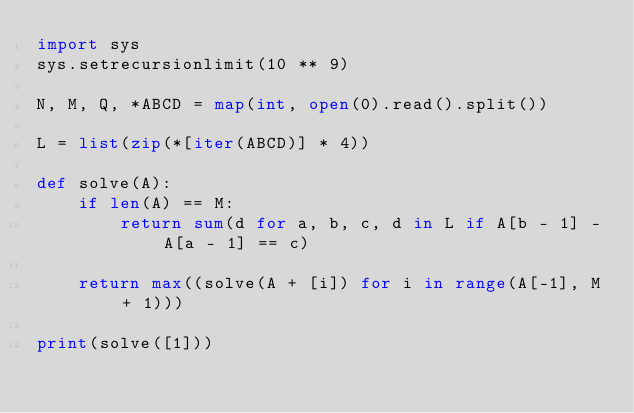Convert code to text. <code><loc_0><loc_0><loc_500><loc_500><_Python_>import sys
sys.setrecursionlimit(10 ** 9)

N, M, Q, *ABCD = map(int, open(0).read().split())

L = list(zip(*[iter(ABCD)] * 4))

def solve(A):
    if len(A) == M:
        return sum(d for a, b, c, d in L if A[b - 1] - A[a - 1] == c)

    return max((solve(A + [i]) for i in range(A[-1], M + 1)))

print(solve([1]))</code> 